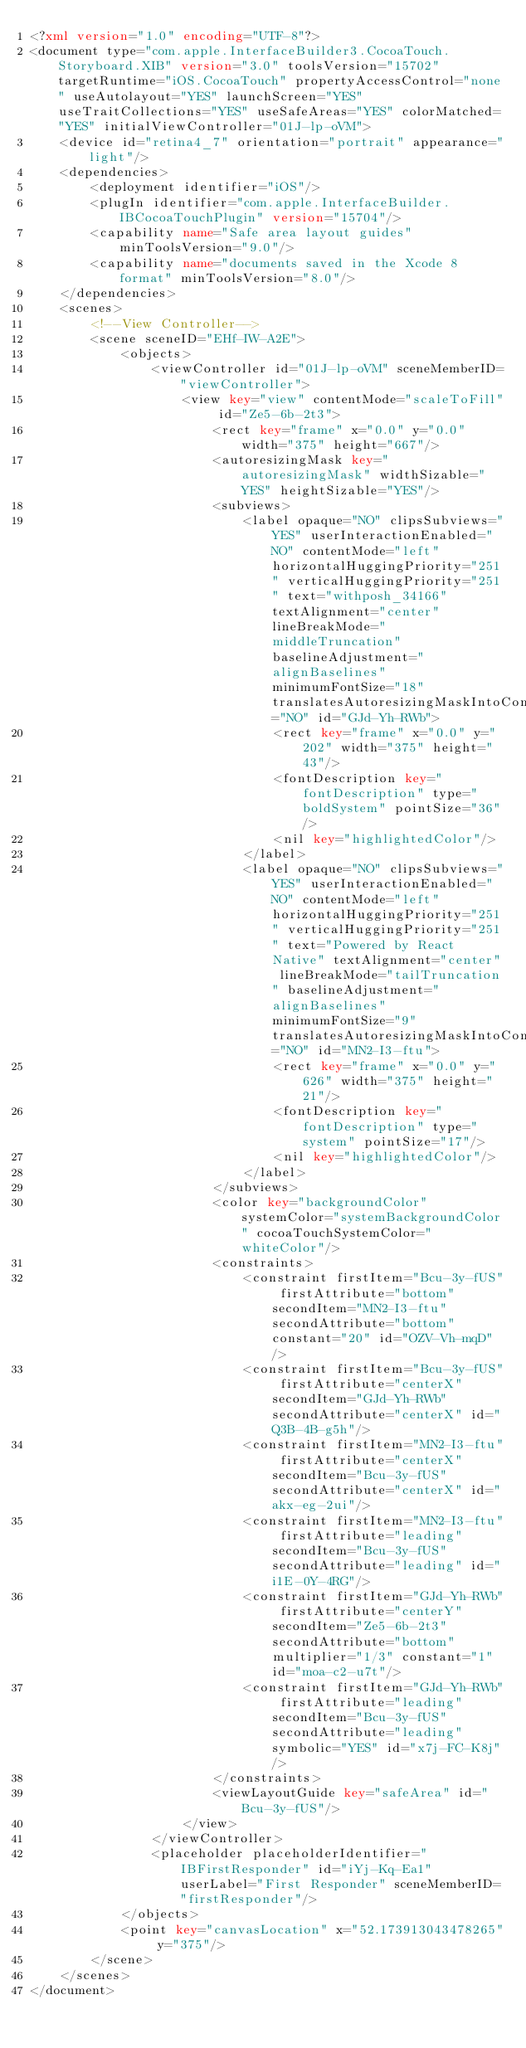<code> <loc_0><loc_0><loc_500><loc_500><_XML_><?xml version="1.0" encoding="UTF-8"?>
<document type="com.apple.InterfaceBuilder3.CocoaTouch.Storyboard.XIB" version="3.0" toolsVersion="15702" targetRuntime="iOS.CocoaTouch" propertyAccessControl="none" useAutolayout="YES" launchScreen="YES" useTraitCollections="YES" useSafeAreas="YES" colorMatched="YES" initialViewController="01J-lp-oVM">
    <device id="retina4_7" orientation="portrait" appearance="light"/>
    <dependencies>
        <deployment identifier="iOS"/>
        <plugIn identifier="com.apple.InterfaceBuilder.IBCocoaTouchPlugin" version="15704"/>
        <capability name="Safe area layout guides" minToolsVersion="9.0"/>
        <capability name="documents saved in the Xcode 8 format" minToolsVersion="8.0"/>
    </dependencies>
    <scenes>
        <!--View Controller-->
        <scene sceneID="EHf-IW-A2E">
            <objects>
                <viewController id="01J-lp-oVM" sceneMemberID="viewController">
                    <view key="view" contentMode="scaleToFill" id="Ze5-6b-2t3">
                        <rect key="frame" x="0.0" y="0.0" width="375" height="667"/>
                        <autoresizingMask key="autoresizingMask" widthSizable="YES" heightSizable="YES"/>
                        <subviews>
                            <label opaque="NO" clipsSubviews="YES" userInteractionEnabled="NO" contentMode="left" horizontalHuggingPriority="251" verticalHuggingPriority="251" text="withposh_34166" textAlignment="center" lineBreakMode="middleTruncation" baselineAdjustment="alignBaselines" minimumFontSize="18" translatesAutoresizingMaskIntoConstraints="NO" id="GJd-Yh-RWb">
                                <rect key="frame" x="0.0" y="202" width="375" height="43"/>
                                <fontDescription key="fontDescription" type="boldSystem" pointSize="36"/>
                                <nil key="highlightedColor"/>
                            </label>
                            <label opaque="NO" clipsSubviews="YES" userInteractionEnabled="NO" contentMode="left" horizontalHuggingPriority="251" verticalHuggingPriority="251" text="Powered by React Native" textAlignment="center" lineBreakMode="tailTruncation" baselineAdjustment="alignBaselines" minimumFontSize="9" translatesAutoresizingMaskIntoConstraints="NO" id="MN2-I3-ftu">
                                <rect key="frame" x="0.0" y="626" width="375" height="21"/>
                                <fontDescription key="fontDescription" type="system" pointSize="17"/>
                                <nil key="highlightedColor"/>
                            </label>
                        </subviews>
                        <color key="backgroundColor" systemColor="systemBackgroundColor" cocoaTouchSystemColor="whiteColor"/>
                        <constraints>
                            <constraint firstItem="Bcu-3y-fUS" firstAttribute="bottom" secondItem="MN2-I3-ftu" secondAttribute="bottom" constant="20" id="OZV-Vh-mqD"/>
                            <constraint firstItem="Bcu-3y-fUS" firstAttribute="centerX" secondItem="GJd-Yh-RWb" secondAttribute="centerX" id="Q3B-4B-g5h"/>
                            <constraint firstItem="MN2-I3-ftu" firstAttribute="centerX" secondItem="Bcu-3y-fUS" secondAttribute="centerX" id="akx-eg-2ui"/>
                            <constraint firstItem="MN2-I3-ftu" firstAttribute="leading" secondItem="Bcu-3y-fUS" secondAttribute="leading" id="i1E-0Y-4RG"/>
                            <constraint firstItem="GJd-Yh-RWb" firstAttribute="centerY" secondItem="Ze5-6b-2t3" secondAttribute="bottom" multiplier="1/3" constant="1" id="moa-c2-u7t"/>
                            <constraint firstItem="GJd-Yh-RWb" firstAttribute="leading" secondItem="Bcu-3y-fUS" secondAttribute="leading" symbolic="YES" id="x7j-FC-K8j"/>
                        </constraints>
                        <viewLayoutGuide key="safeArea" id="Bcu-3y-fUS"/>
                    </view>
                </viewController>
                <placeholder placeholderIdentifier="IBFirstResponder" id="iYj-Kq-Ea1" userLabel="First Responder" sceneMemberID="firstResponder"/>
            </objects>
            <point key="canvasLocation" x="52.173913043478265" y="375"/>
        </scene>
    </scenes>
</document>
</code> 